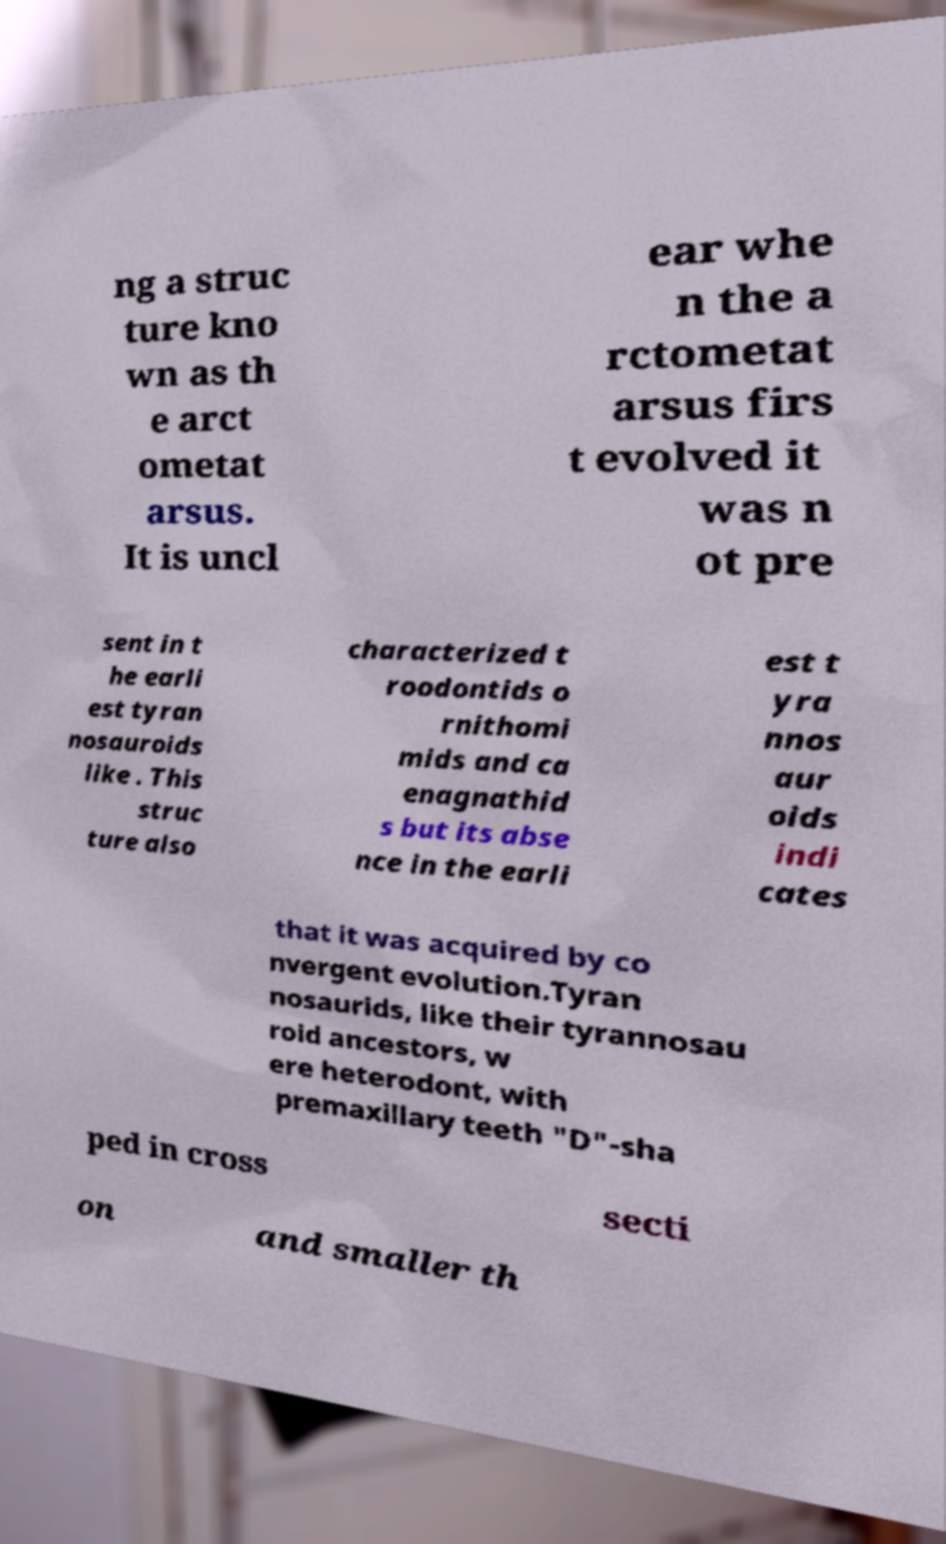I need the written content from this picture converted into text. Can you do that? ng a struc ture kno wn as th e arct ometat arsus. It is uncl ear whe n the a rctometat arsus firs t evolved it was n ot pre sent in t he earli est tyran nosauroids like . This struc ture also characterized t roodontids o rnithomi mids and ca enagnathid s but its abse nce in the earli est t yra nnos aur oids indi cates that it was acquired by co nvergent evolution.Tyran nosaurids, like their tyrannosau roid ancestors, w ere heterodont, with premaxillary teeth "D"-sha ped in cross secti on and smaller th 